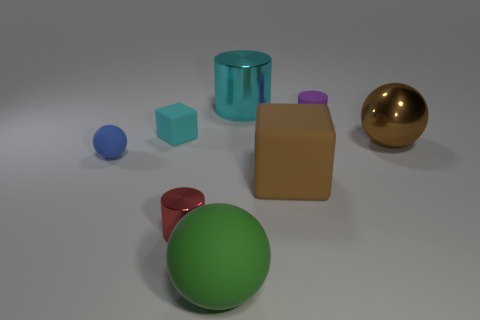Add 7 brown matte objects. How many brown matte objects are left? 8 Add 6 large matte spheres. How many large matte spheres exist? 7 Add 1 yellow spheres. How many objects exist? 9 Subtract all cyan cubes. How many cubes are left? 1 Subtract all big cylinders. How many cylinders are left? 2 Subtract 0 red spheres. How many objects are left? 8 Subtract all cylinders. How many objects are left? 5 Subtract 1 cylinders. How many cylinders are left? 2 Subtract all green cubes. Subtract all yellow cylinders. How many cubes are left? 2 Subtract all gray balls. How many cyan cubes are left? 1 